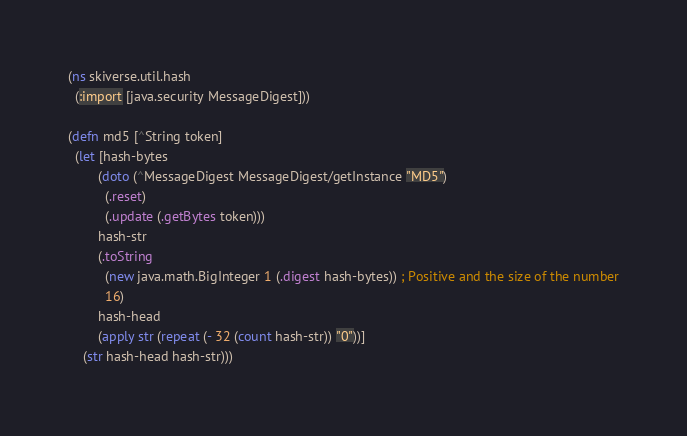Convert code to text. <code><loc_0><loc_0><loc_500><loc_500><_Clojure_>(ns skiverse.util.hash
  (:import [java.security MessageDigest]))

(defn md5 [^String token]
  (let [hash-bytes
        (doto (^MessageDigest MessageDigest/getInstance "MD5")
          (.reset)
          (.update (.getBytes token)))
        hash-str
        (.toString
          (new java.math.BigInteger 1 (.digest hash-bytes)) ; Positive and the size of the number
          16)
        hash-head
        (apply str (repeat (- 32 (count hash-str)) "0"))]
    (str hash-head hash-str)))
</code> 